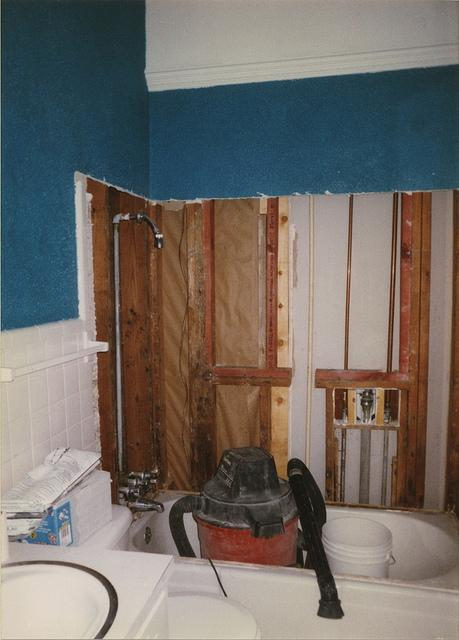Why did they open up the wall? Please explain your reasoning. leak. There is a vacuum to clean up water 